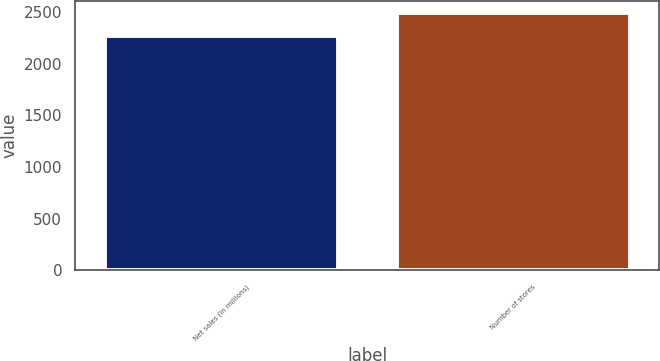Convert chart to OTSL. <chart><loc_0><loc_0><loc_500><loc_500><bar_chart><fcel>Net sales (in millions)<fcel>Number of stores<nl><fcel>2269.5<fcel>2490<nl></chart> 